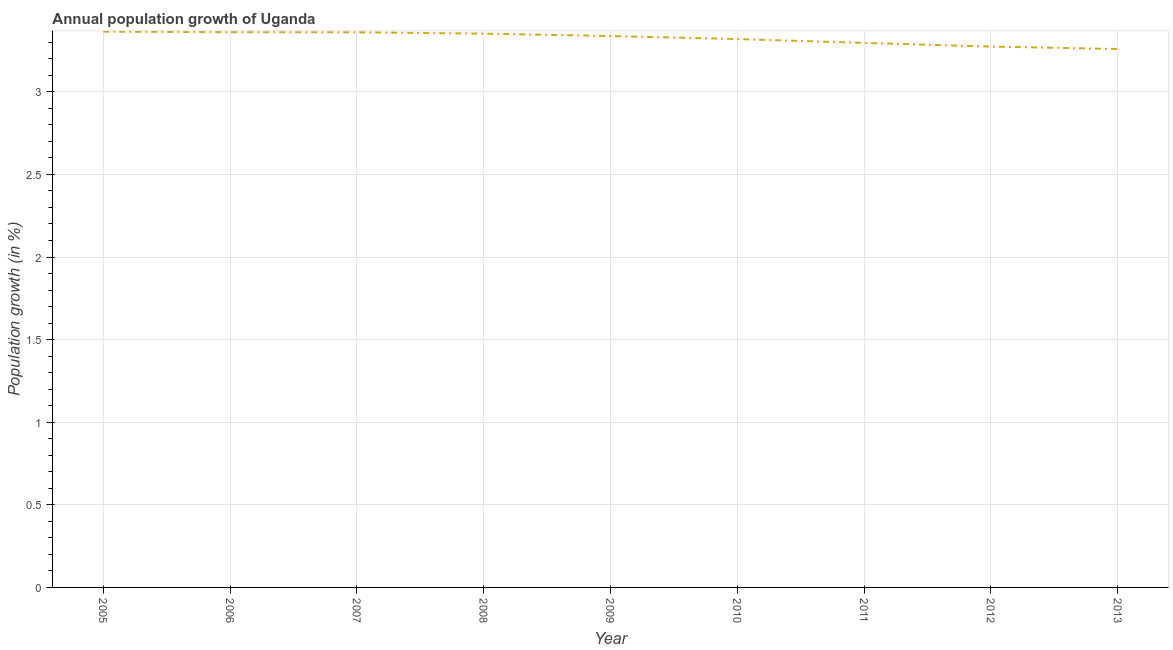What is the population growth in 2007?
Your response must be concise. 3.36. Across all years, what is the maximum population growth?
Your response must be concise. 3.36. Across all years, what is the minimum population growth?
Your answer should be compact. 3.26. In which year was the population growth maximum?
Ensure brevity in your answer.  2005. What is the sum of the population growth?
Make the answer very short. 29.92. What is the difference between the population growth in 2006 and 2013?
Your response must be concise. 0.1. What is the average population growth per year?
Give a very brief answer. 3.32. What is the median population growth?
Your answer should be very brief. 3.34. In how many years, is the population growth greater than 0.1 %?
Provide a short and direct response. 9. Do a majority of the years between 2009 and 2007 (inclusive) have population growth greater than 2.4 %?
Keep it short and to the point. No. What is the ratio of the population growth in 2010 to that in 2011?
Make the answer very short. 1.01. Is the population growth in 2012 less than that in 2013?
Offer a terse response. No. Is the difference between the population growth in 2008 and 2013 greater than the difference between any two years?
Give a very brief answer. No. What is the difference between the highest and the second highest population growth?
Offer a very short reply. 0. Is the sum of the population growth in 2007 and 2011 greater than the maximum population growth across all years?
Your answer should be very brief. Yes. What is the difference between the highest and the lowest population growth?
Your answer should be compact. 0.1. In how many years, is the population growth greater than the average population growth taken over all years?
Give a very brief answer. 5. How many lines are there?
Make the answer very short. 1. How many years are there in the graph?
Your answer should be very brief. 9. Are the values on the major ticks of Y-axis written in scientific E-notation?
Offer a terse response. No. What is the title of the graph?
Provide a short and direct response. Annual population growth of Uganda. What is the label or title of the Y-axis?
Offer a very short reply. Population growth (in %). What is the Population growth (in %) in 2005?
Offer a terse response. 3.36. What is the Population growth (in %) of 2006?
Make the answer very short. 3.36. What is the Population growth (in %) in 2007?
Your response must be concise. 3.36. What is the Population growth (in %) of 2008?
Provide a short and direct response. 3.35. What is the Population growth (in %) of 2009?
Make the answer very short. 3.34. What is the Population growth (in %) in 2010?
Provide a succinct answer. 3.32. What is the Population growth (in %) of 2011?
Ensure brevity in your answer.  3.3. What is the Population growth (in %) in 2012?
Give a very brief answer. 3.27. What is the Population growth (in %) in 2013?
Keep it short and to the point. 3.26. What is the difference between the Population growth (in %) in 2005 and 2006?
Your answer should be very brief. 0. What is the difference between the Population growth (in %) in 2005 and 2007?
Provide a short and direct response. 0. What is the difference between the Population growth (in %) in 2005 and 2008?
Provide a succinct answer. 0.01. What is the difference between the Population growth (in %) in 2005 and 2009?
Give a very brief answer. 0.03. What is the difference between the Population growth (in %) in 2005 and 2010?
Provide a short and direct response. 0.04. What is the difference between the Population growth (in %) in 2005 and 2011?
Make the answer very short. 0.07. What is the difference between the Population growth (in %) in 2005 and 2012?
Offer a very short reply. 0.09. What is the difference between the Population growth (in %) in 2005 and 2013?
Make the answer very short. 0.1. What is the difference between the Population growth (in %) in 2006 and 2007?
Give a very brief answer. 0. What is the difference between the Population growth (in %) in 2006 and 2008?
Make the answer very short. 0.01. What is the difference between the Population growth (in %) in 2006 and 2009?
Provide a short and direct response. 0.02. What is the difference between the Population growth (in %) in 2006 and 2010?
Provide a succinct answer. 0.04. What is the difference between the Population growth (in %) in 2006 and 2011?
Offer a very short reply. 0.06. What is the difference between the Population growth (in %) in 2006 and 2012?
Your response must be concise. 0.09. What is the difference between the Population growth (in %) in 2006 and 2013?
Provide a short and direct response. 0.1. What is the difference between the Population growth (in %) in 2007 and 2008?
Provide a short and direct response. 0.01. What is the difference between the Population growth (in %) in 2007 and 2009?
Ensure brevity in your answer.  0.02. What is the difference between the Population growth (in %) in 2007 and 2010?
Your response must be concise. 0.04. What is the difference between the Population growth (in %) in 2007 and 2011?
Your response must be concise. 0.06. What is the difference between the Population growth (in %) in 2007 and 2012?
Provide a succinct answer. 0.09. What is the difference between the Population growth (in %) in 2007 and 2013?
Offer a terse response. 0.1. What is the difference between the Population growth (in %) in 2008 and 2009?
Offer a terse response. 0.01. What is the difference between the Population growth (in %) in 2008 and 2010?
Your response must be concise. 0.03. What is the difference between the Population growth (in %) in 2008 and 2011?
Your answer should be very brief. 0.06. What is the difference between the Population growth (in %) in 2008 and 2012?
Your response must be concise. 0.08. What is the difference between the Population growth (in %) in 2008 and 2013?
Offer a very short reply. 0.09. What is the difference between the Population growth (in %) in 2009 and 2010?
Your answer should be compact. 0.02. What is the difference between the Population growth (in %) in 2009 and 2011?
Your response must be concise. 0.04. What is the difference between the Population growth (in %) in 2009 and 2012?
Your answer should be compact. 0.06. What is the difference between the Population growth (in %) in 2009 and 2013?
Your answer should be very brief. 0.08. What is the difference between the Population growth (in %) in 2010 and 2011?
Make the answer very short. 0.02. What is the difference between the Population growth (in %) in 2010 and 2012?
Your answer should be compact. 0.05. What is the difference between the Population growth (in %) in 2010 and 2013?
Give a very brief answer. 0.06. What is the difference between the Population growth (in %) in 2011 and 2012?
Keep it short and to the point. 0.02. What is the difference between the Population growth (in %) in 2011 and 2013?
Give a very brief answer. 0.04. What is the difference between the Population growth (in %) in 2012 and 2013?
Make the answer very short. 0.01. What is the ratio of the Population growth (in %) in 2005 to that in 2006?
Offer a very short reply. 1. What is the ratio of the Population growth (in %) in 2005 to that in 2008?
Your answer should be very brief. 1. What is the ratio of the Population growth (in %) in 2005 to that in 2012?
Offer a very short reply. 1.03. What is the ratio of the Population growth (in %) in 2005 to that in 2013?
Your answer should be compact. 1.03. What is the ratio of the Population growth (in %) in 2006 to that in 2009?
Keep it short and to the point. 1.01. What is the ratio of the Population growth (in %) in 2006 to that in 2013?
Keep it short and to the point. 1.03. What is the ratio of the Population growth (in %) in 2007 to that in 2008?
Give a very brief answer. 1. What is the ratio of the Population growth (in %) in 2007 to that in 2009?
Offer a terse response. 1.01. What is the ratio of the Population growth (in %) in 2007 to that in 2011?
Your answer should be very brief. 1.02. What is the ratio of the Population growth (in %) in 2007 to that in 2013?
Provide a short and direct response. 1.03. What is the ratio of the Population growth (in %) in 2008 to that in 2009?
Your response must be concise. 1. What is the ratio of the Population growth (in %) in 2009 to that in 2010?
Your response must be concise. 1.01. What is the ratio of the Population growth (in %) in 2009 to that in 2011?
Offer a terse response. 1.01. What is the ratio of the Population growth (in %) in 2010 to that in 2012?
Give a very brief answer. 1.01. What is the ratio of the Population growth (in %) in 2010 to that in 2013?
Provide a succinct answer. 1.02. What is the ratio of the Population growth (in %) in 2011 to that in 2012?
Offer a terse response. 1.01. What is the ratio of the Population growth (in %) in 2012 to that in 2013?
Your response must be concise. 1. 